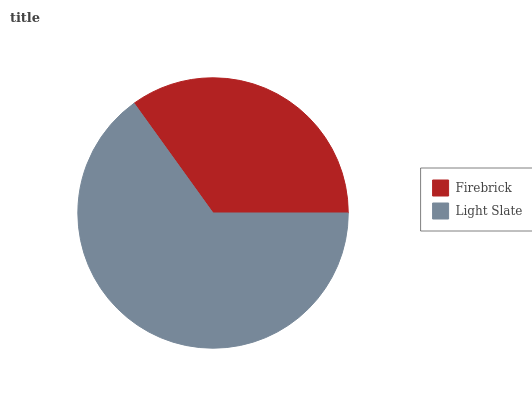Is Firebrick the minimum?
Answer yes or no. Yes. Is Light Slate the maximum?
Answer yes or no. Yes. Is Light Slate the minimum?
Answer yes or no. No. Is Light Slate greater than Firebrick?
Answer yes or no. Yes. Is Firebrick less than Light Slate?
Answer yes or no. Yes. Is Firebrick greater than Light Slate?
Answer yes or no. No. Is Light Slate less than Firebrick?
Answer yes or no. No. Is Light Slate the high median?
Answer yes or no. Yes. Is Firebrick the low median?
Answer yes or no. Yes. Is Firebrick the high median?
Answer yes or no. No. Is Light Slate the low median?
Answer yes or no. No. 